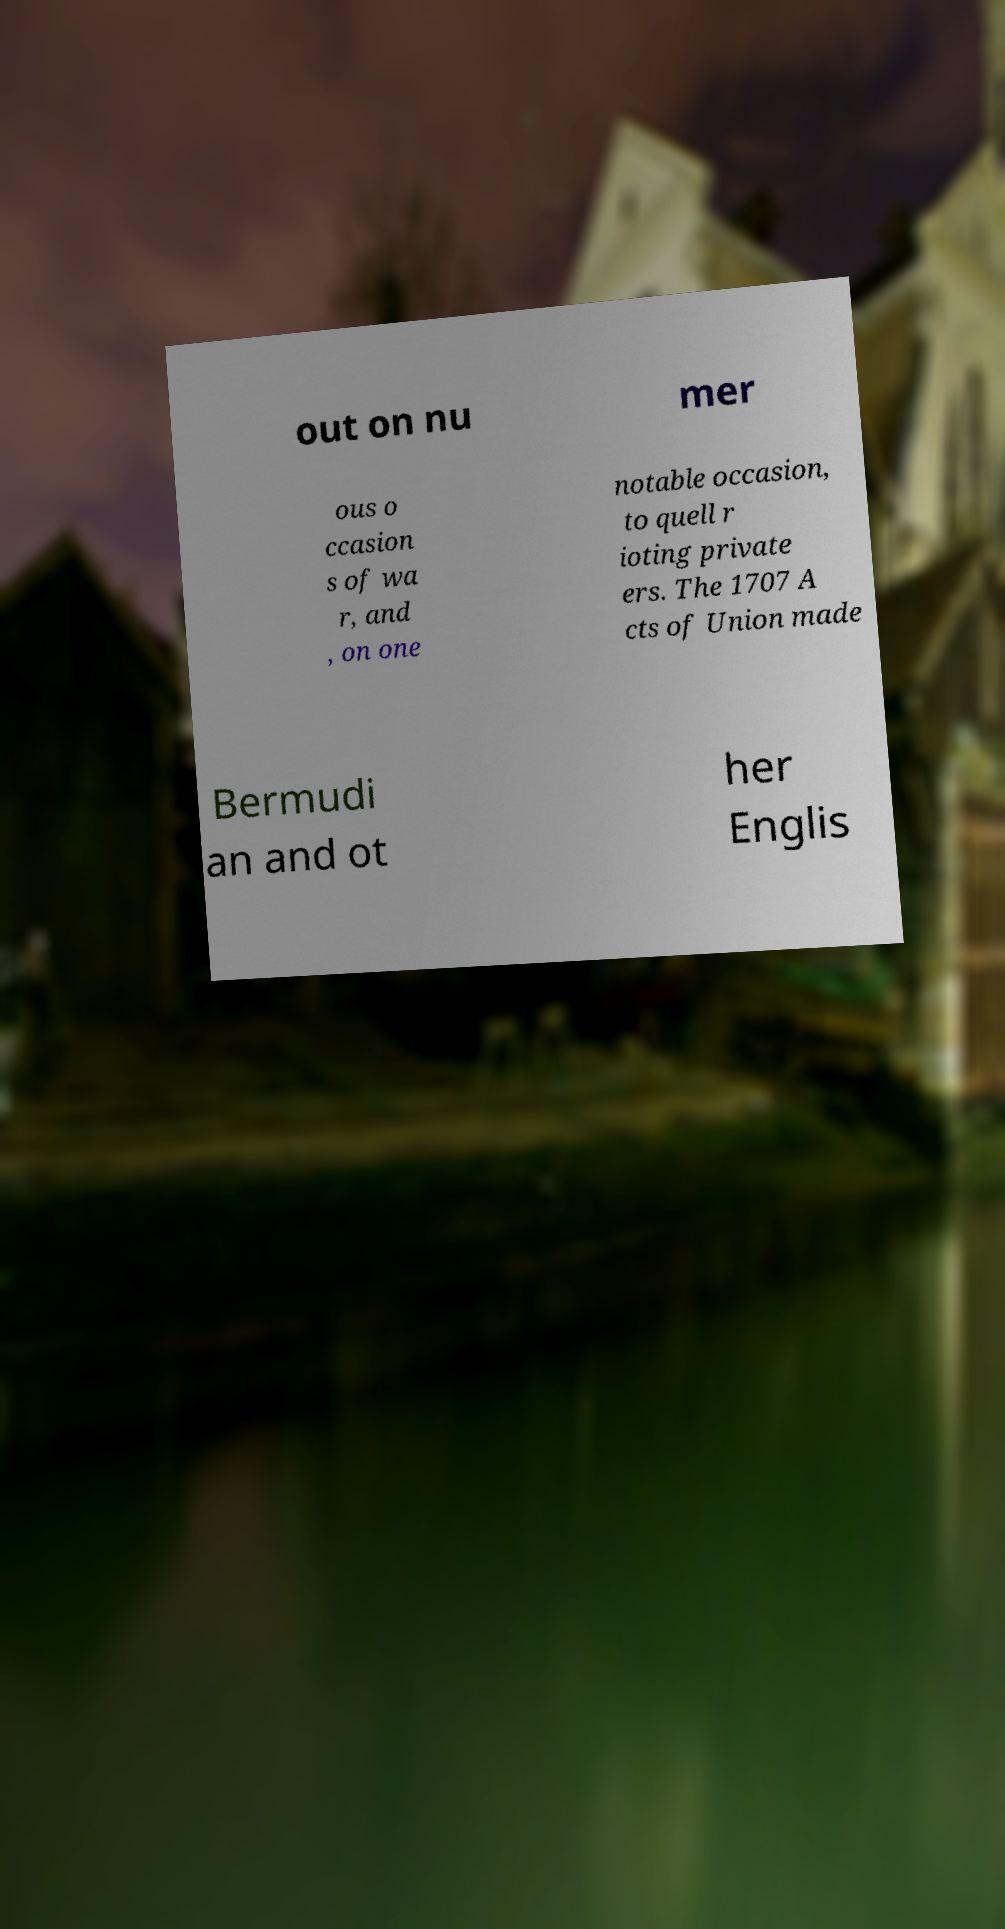Please read and relay the text visible in this image. What does it say? out on nu mer ous o ccasion s of wa r, and , on one notable occasion, to quell r ioting private ers. The 1707 A cts of Union made Bermudi an and ot her Englis 